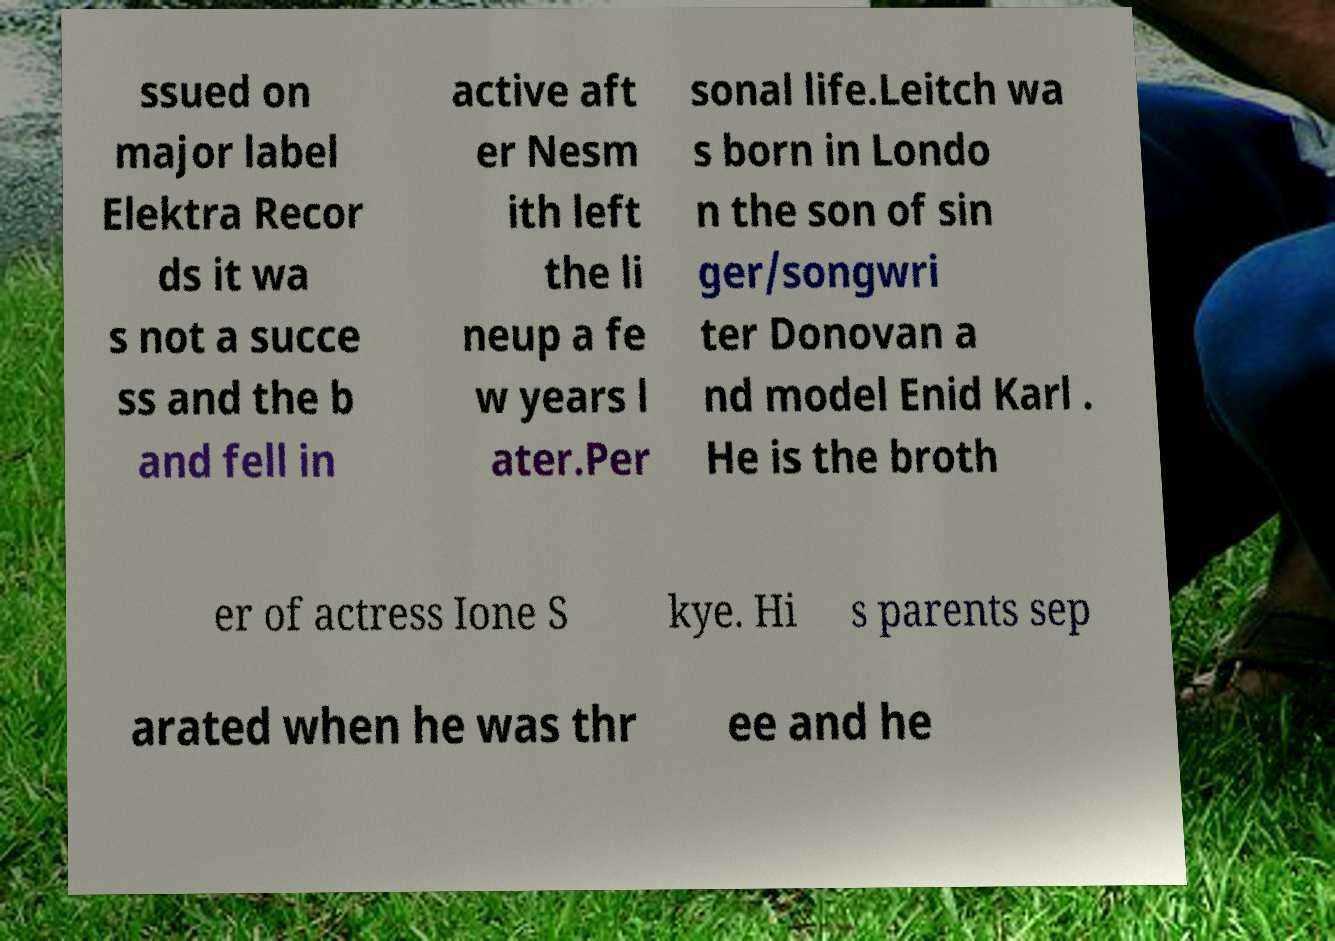Could you extract and type out the text from this image? ssued on major label Elektra Recor ds it wa s not a succe ss and the b and fell in active aft er Nesm ith left the li neup a fe w years l ater.Per sonal life.Leitch wa s born in Londo n the son of sin ger/songwri ter Donovan a nd model Enid Karl . He is the broth er of actress Ione S kye. Hi s parents sep arated when he was thr ee and he 